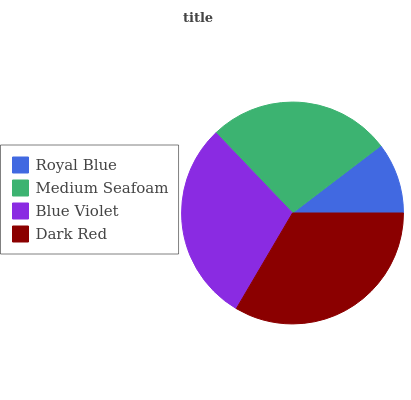Is Royal Blue the minimum?
Answer yes or no. Yes. Is Dark Red the maximum?
Answer yes or no. Yes. Is Medium Seafoam the minimum?
Answer yes or no. No. Is Medium Seafoam the maximum?
Answer yes or no. No. Is Medium Seafoam greater than Royal Blue?
Answer yes or no. Yes. Is Royal Blue less than Medium Seafoam?
Answer yes or no. Yes. Is Royal Blue greater than Medium Seafoam?
Answer yes or no. No. Is Medium Seafoam less than Royal Blue?
Answer yes or no. No. Is Blue Violet the high median?
Answer yes or no. Yes. Is Medium Seafoam the low median?
Answer yes or no. Yes. Is Royal Blue the high median?
Answer yes or no. No. Is Blue Violet the low median?
Answer yes or no. No. 